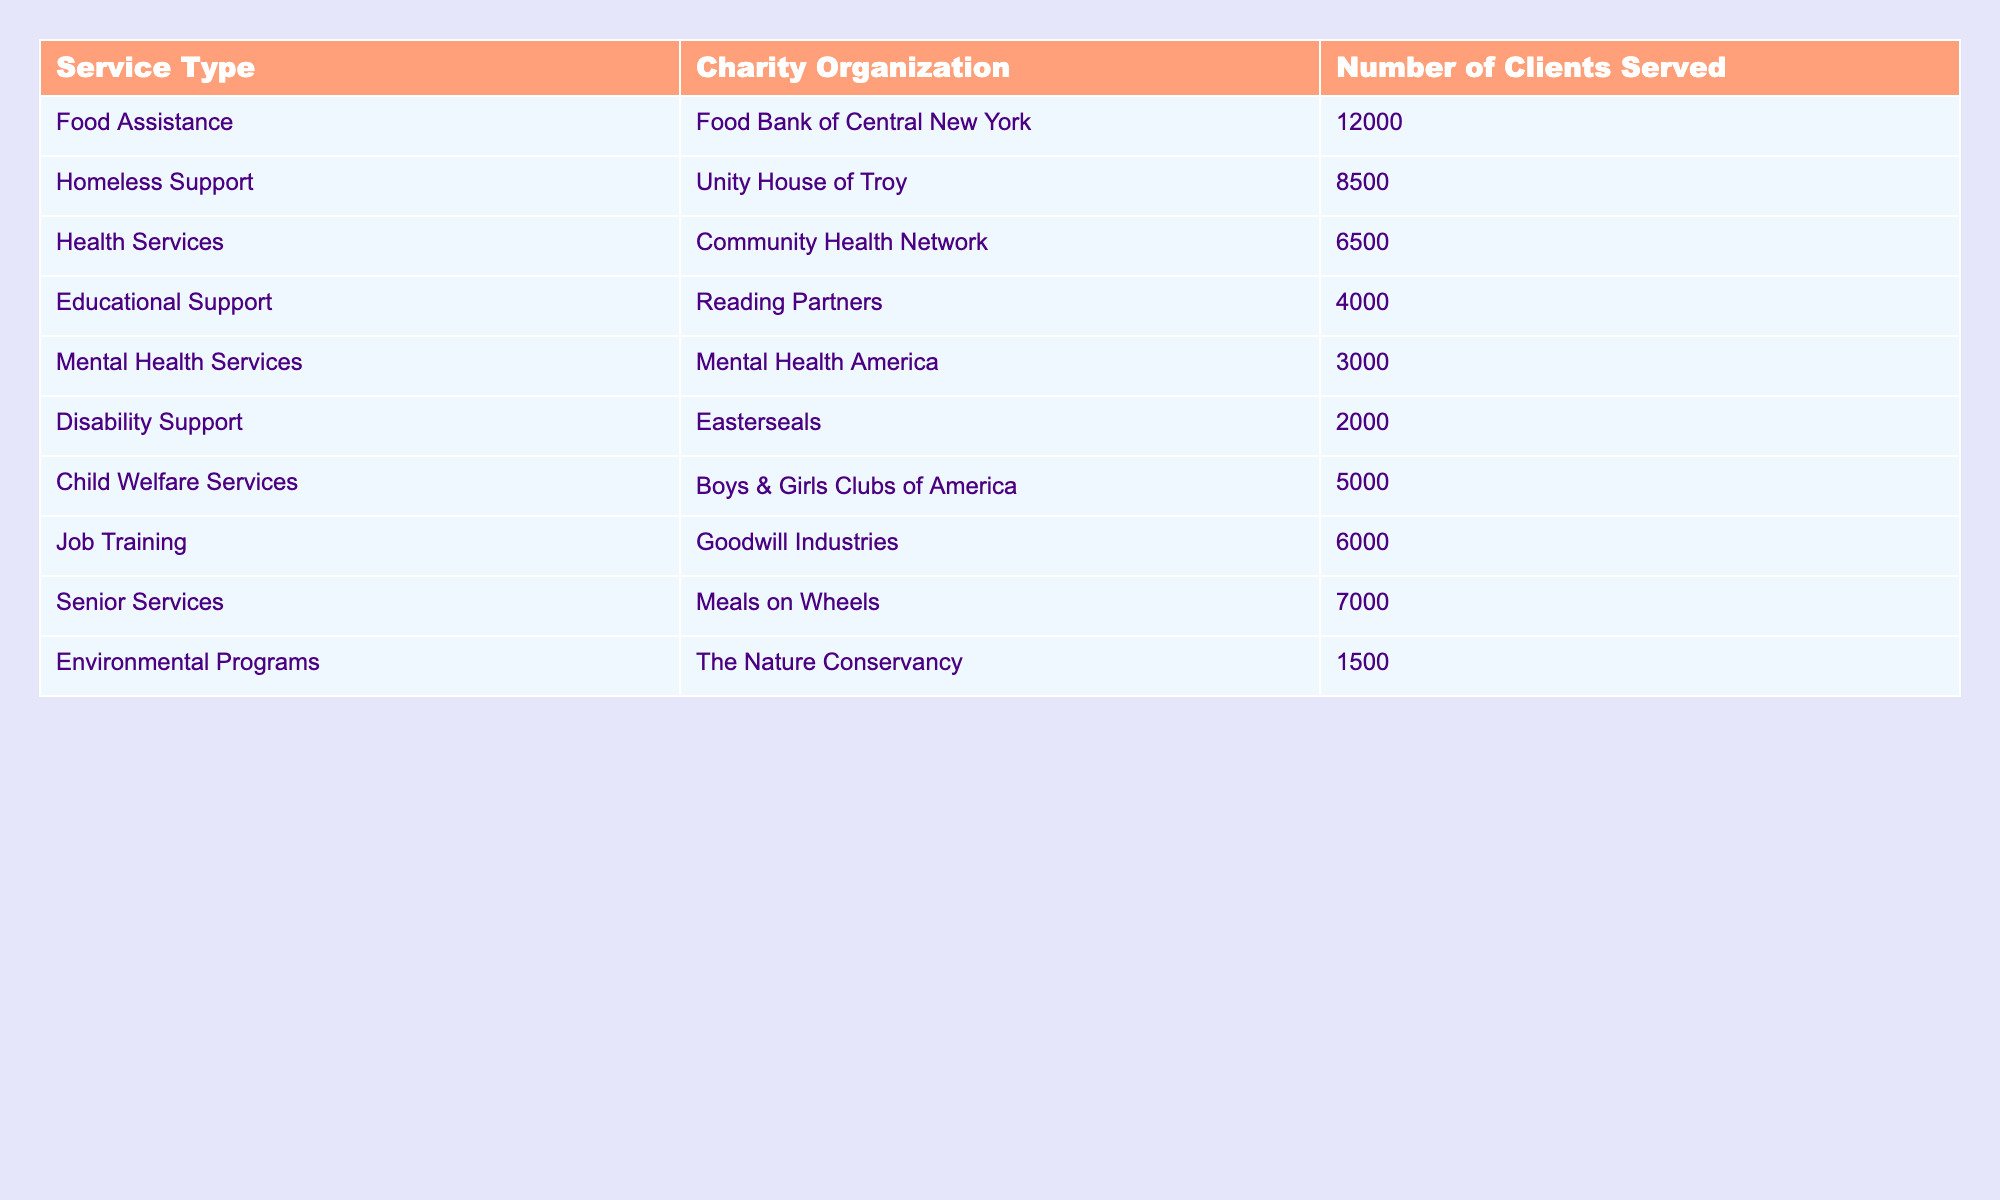What's the service type that served the most clients? Looking at the table, the number of clients served for each service type reveals that "Food Assistance" provided services to 12,000 clients, which is the highest number among all categories.
Answer: Food Assistance How many clients were served by Unity House of Troy? In the table, "Unity House of Troy" is listed under the "Homeless Support" service type, and it shows that they served 8,500 clients.
Answer: 8,500 Which service type had the least number of clients served? By reviewing the table, "Environmental Programs" offered by "The Nature Conservancy" served the fewest clients, totaling 1,500.
Answer: Environmental Programs What is the total number of clients served by all charities listed? To find the total, add up the number of clients served for each service: 12,000 + 8,500 + 6,500 + 4,000 + 3,000 + 2,000 + 5,000 + 6,000 + 7,000 + 1,500 = 55,500.
Answer: 55,500 Did more clients receive job training or mental health services? Comparing the two values: "Job Training" served 6,000 clients while "Mental Health Services" served 3,000 clients. Therefore, job training had more clients served.
Answer: Yes, more clients received job training What's the difference in clients served between Senior Services and Disability Support? Senior Services served 7,000 clients, while Disability Support served 2,000 clients. The difference is 7,000 - 2,000 = 5,000 clients.
Answer: 5,000 What is the average number of clients served across all service types? To find the average, first calculate the total number of clients (55,500 from earlier), then divide by the number of service types listed (10): 55,500 / 10 = 5,550.
Answer: 5,550 How many more clients were served by Meals on Wheels compared to Reading Partners? "Meals on Wheels" served 7,000 clients and "Reading Partners" served 4,000 clients. The difference is 7,000 - 4,000 = 3,000.
Answer: 3,000 Is the number of clients served by Community Health Network greater than the total served by both Easterseals and Boys & Girls Clubs of America combined? "Community Health Network" served 6,500 clients. "Easterseals" and "Boys & Girls Clubs of America" served 2,000 and 5,000 clients respectively, totaling 2,000 + 5,000 = 7,000. Since 6,500 < 7,000, the statement is false.
Answer: No Which organizations provided services to more than 5,000 clients? By analyzing the table, the organizations with more than 5,000 clients served are: "Food Bank of Central New York" (12,000), "Unity House of Troy" (8,500), "Meals on Wheels" (7,000), and "Goodwill Industries" (6,000).
Answer: 4 organizations provided services to more than 5,000 clients 